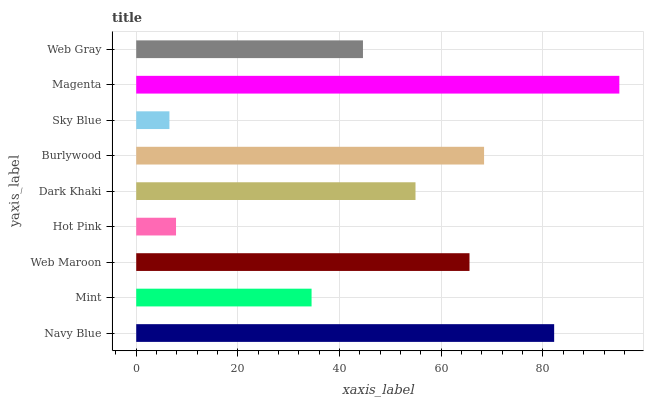Is Sky Blue the minimum?
Answer yes or no. Yes. Is Magenta the maximum?
Answer yes or no. Yes. Is Mint the minimum?
Answer yes or no. No. Is Mint the maximum?
Answer yes or no. No. Is Navy Blue greater than Mint?
Answer yes or no. Yes. Is Mint less than Navy Blue?
Answer yes or no. Yes. Is Mint greater than Navy Blue?
Answer yes or no. No. Is Navy Blue less than Mint?
Answer yes or no. No. Is Dark Khaki the high median?
Answer yes or no. Yes. Is Dark Khaki the low median?
Answer yes or no. Yes. Is Hot Pink the high median?
Answer yes or no. No. Is Mint the low median?
Answer yes or no. No. 